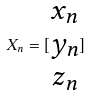<formula> <loc_0><loc_0><loc_500><loc_500>X _ { n } = [ \begin{matrix} x _ { n } \\ y _ { n } \\ z _ { n } \end{matrix} ]</formula> 